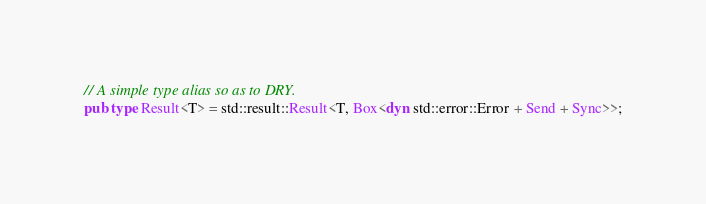Convert code to text. <code><loc_0><loc_0><loc_500><loc_500><_Rust_>// A simple type alias so as to DRY.
pub type Result<T> = std::result::Result<T, Box<dyn std::error::Error + Send + Sync>>;
</code> 